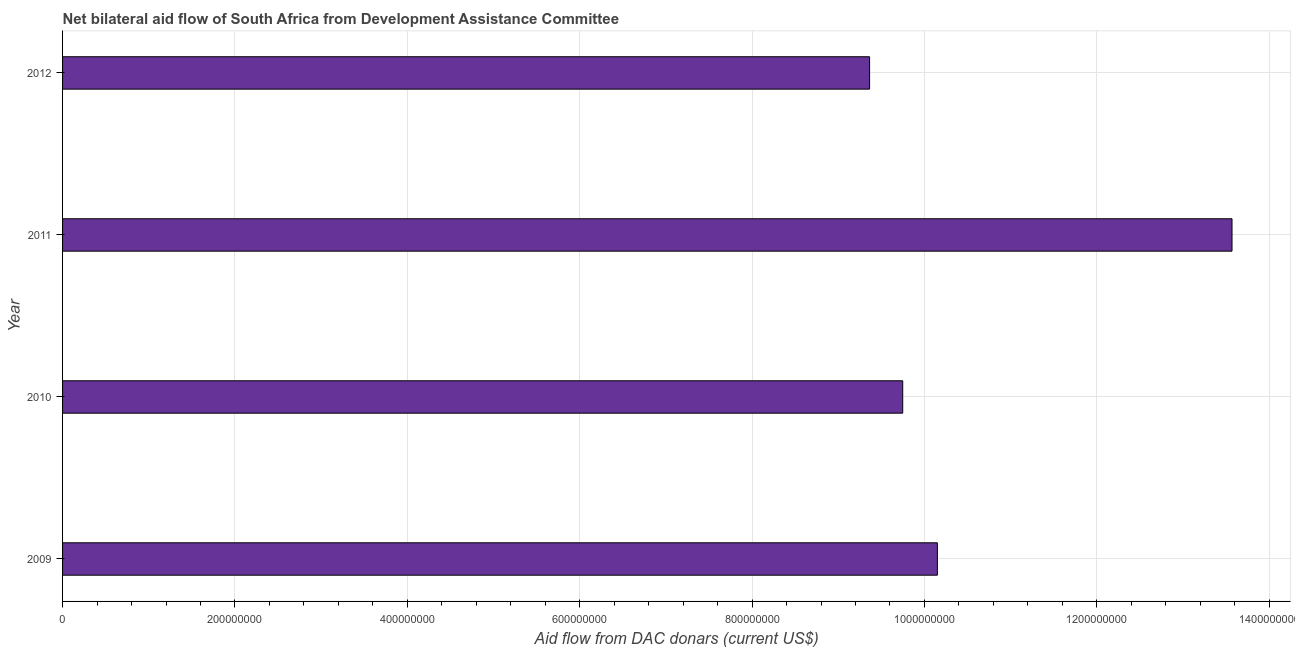What is the title of the graph?
Provide a succinct answer. Net bilateral aid flow of South Africa from Development Assistance Committee. What is the label or title of the X-axis?
Make the answer very short. Aid flow from DAC donars (current US$). What is the net bilateral aid flows from dac donors in 2011?
Provide a short and direct response. 1.36e+09. Across all years, what is the maximum net bilateral aid flows from dac donors?
Ensure brevity in your answer.  1.36e+09. Across all years, what is the minimum net bilateral aid flows from dac donors?
Your answer should be compact. 9.36e+08. What is the sum of the net bilateral aid flows from dac donors?
Your answer should be very brief. 4.28e+09. What is the difference between the net bilateral aid flows from dac donors in 2010 and 2011?
Ensure brevity in your answer.  -3.82e+08. What is the average net bilateral aid flows from dac donors per year?
Your answer should be very brief. 1.07e+09. What is the median net bilateral aid flows from dac donors?
Ensure brevity in your answer.  9.95e+08. In how many years, is the net bilateral aid flows from dac donors greater than 80000000 US$?
Your response must be concise. 4. What is the ratio of the net bilateral aid flows from dac donors in 2010 to that in 2011?
Keep it short and to the point. 0.72. Is the difference between the net bilateral aid flows from dac donors in 2009 and 2011 greater than the difference between any two years?
Your answer should be compact. No. What is the difference between the highest and the second highest net bilateral aid flows from dac donors?
Give a very brief answer. 3.42e+08. What is the difference between the highest and the lowest net bilateral aid flows from dac donors?
Your response must be concise. 4.20e+08. In how many years, is the net bilateral aid flows from dac donors greater than the average net bilateral aid flows from dac donors taken over all years?
Your answer should be very brief. 1. How many bars are there?
Your answer should be very brief. 4. How many years are there in the graph?
Keep it short and to the point. 4. What is the difference between two consecutive major ticks on the X-axis?
Keep it short and to the point. 2.00e+08. What is the Aid flow from DAC donars (current US$) of 2009?
Your answer should be compact. 1.01e+09. What is the Aid flow from DAC donars (current US$) of 2010?
Offer a very short reply. 9.75e+08. What is the Aid flow from DAC donars (current US$) of 2011?
Your answer should be compact. 1.36e+09. What is the Aid flow from DAC donars (current US$) of 2012?
Make the answer very short. 9.36e+08. What is the difference between the Aid flow from DAC donars (current US$) in 2009 and 2010?
Your answer should be compact. 4.02e+07. What is the difference between the Aid flow from DAC donars (current US$) in 2009 and 2011?
Your answer should be very brief. -3.42e+08. What is the difference between the Aid flow from DAC donars (current US$) in 2009 and 2012?
Keep it short and to the point. 7.86e+07. What is the difference between the Aid flow from DAC donars (current US$) in 2010 and 2011?
Your answer should be compact. -3.82e+08. What is the difference between the Aid flow from DAC donars (current US$) in 2010 and 2012?
Keep it short and to the point. 3.84e+07. What is the difference between the Aid flow from DAC donars (current US$) in 2011 and 2012?
Ensure brevity in your answer.  4.20e+08. What is the ratio of the Aid flow from DAC donars (current US$) in 2009 to that in 2010?
Your answer should be compact. 1.04. What is the ratio of the Aid flow from DAC donars (current US$) in 2009 to that in 2011?
Your response must be concise. 0.75. What is the ratio of the Aid flow from DAC donars (current US$) in 2009 to that in 2012?
Your answer should be compact. 1.08. What is the ratio of the Aid flow from DAC donars (current US$) in 2010 to that in 2011?
Ensure brevity in your answer.  0.72. What is the ratio of the Aid flow from DAC donars (current US$) in 2010 to that in 2012?
Provide a succinct answer. 1.04. What is the ratio of the Aid flow from DAC donars (current US$) in 2011 to that in 2012?
Make the answer very short. 1.45. 